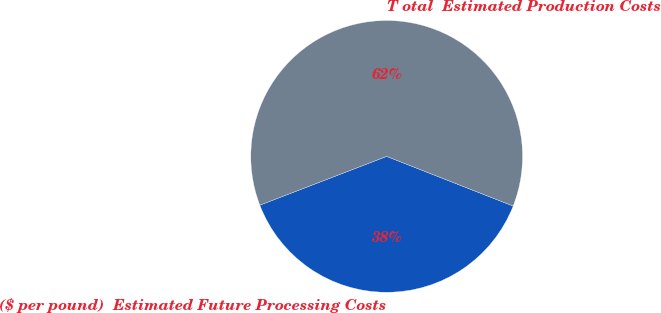Convert chart to OTSL. <chart><loc_0><loc_0><loc_500><loc_500><pie_chart><fcel>($ per pound)  Estimated Future Processing Costs<fcel>T otal  Estimated Production Costs<nl><fcel>38.2%<fcel>61.8%<nl></chart> 